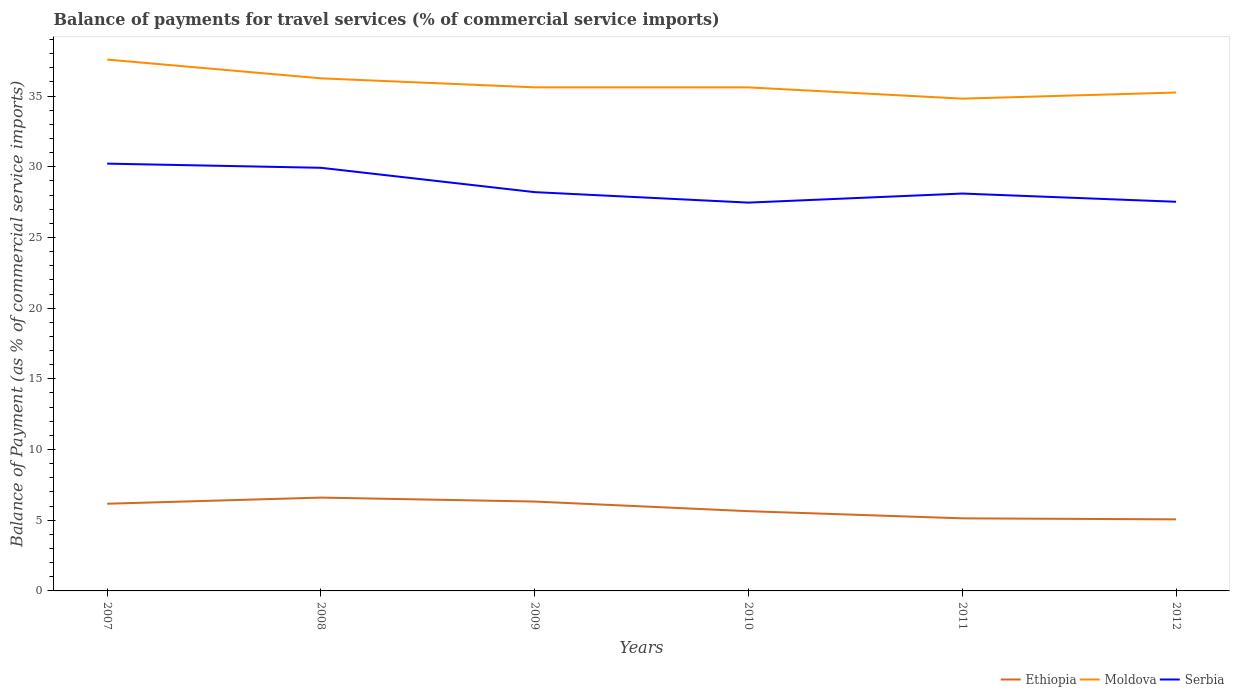How many different coloured lines are there?
Offer a terse response. 3. Across all years, what is the maximum balance of payments for travel services in Moldova?
Offer a very short reply. 34.82. What is the total balance of payments for travel services in Ethiopia in the graph?
Provide a short and direct response. 1.19. What is the difference between the highest and the second highest balance of payments for travel services in Moldova?
Your response must be concise. 2.76. What is the difference between the highest and the lowest balance of payments for travel services in Moldova?
Offer a terse response. 2. Are the values on the major ticks of Y-axis written in scientific E-notation?
Offer a terse response. No. Where does the legend appear in the graph?
Your answer should be very brief. Bottom right. How are the legend labels stacked?
Offer a very short reply. Horizontal. What is the title of the graph?
Ensure brevity in your answer.  Balance of payments for travel services (% of commercial service imports). What is the label or title of the Y-axis?
Your answer should be compact. Balance of Payment (as % of commercial service imports). What is the Balance of Payment (as % of commercial service imports) of Ethiopia in 2007?
Make the answer very short. 6.17. What is the Balance of Payment (as % of commercial service imports) of Moldova in 2007?
Give a very brief answer. 37.58. What is the Balance of Payment (as % of commercial service imports) of Serbia in 2007?
Offer a very short reply. 30.22. What is the Balance of Payment (as % of commercial service imports) of Ethiopia in 2008?
Provide a short and direct response. 6.6. What is the Balance of Payment (as % of commercial service imports) in Moldova in 2008?
Make the answer very short. 36.26. What is the Balance of Payment (as % of commercial service imports) of Serbia in 2008?
Your answer should be compact. 29.93. What is the Balance of Payment (as % of commercial service imports) of Ethiopia in 2009?
Ensure brevity in your answer.  6.32. What is the Balance of Payment (as % of commercial service imports) in Moldova in 2009?
Make the answer very short. 35.62. What is the Balance of Payment (as % of commercial service imports) of Serbia in 2009?
Keep it short and to the point. 28.21. What is the Balance of Payment (as % of commercial service imports) in Ethiopia in 2010?
Ensure brevity in your answer.  5.64. What is the Balance of Payment (as % of commercial service imports) in Moldova in 2010?
Ensure brevity in your answer.  35.61. What is the Balance of Payment (as % of commercial service imports) in Serbia in 2010?
Give a very brief answer. 27.47. What is the Balance of Payment (as % of commercial service imports) in Ethiopia in 2011?
Your response must be concise. 5.13. What is the Balance of Payment (as % of commercial service imports) in Moldova in 2011?
Your answer should be compact. 34.82. What is the Balance of Payment (as % of commercial service imports) of Serbia in 2011?
Provide a succinct answer. 28.11. What is the Balance of Payment (as % of commercial service imports) of Ethiopia in 2012?
Your response must be concise. 5.06. What is the Balance of Payment (as % of commercial service imports) of Moldova in 2012?
Give a very brief answer. 35.25. What is the Balance of Payment (as % of commercial service imports) of Serbia in 2012?
Offer a terse response. 27.53. Across all years, what is the maximum Balance of Payment (as % of commercial service imports) in Ethiopia?
Keep it short and to the point. 6.6. Across all years, what is the maximum Balance of Payment (as % of commercial service imports) in Moldova?
Your response must be concise. 37.58. Across all years, what is the maximum Balance of Payment (as % of commercial service imports) of Serbia?
Your answer should be very brief. 30.22. Across all years, what is the minimum Balance of Payment (as % of commercial service imports) in Ethiopia?
Provide a short and direct response. 5.06. Across all years, what is the minimum Balance of Payment (as % of commercial service imports) in Moldova?
Ensure brevity in your answer.  34.82. Across all years, what is the minimum Balance of Payment (as % of commercial service imports) of Serbia?
Give a very brief answer. 27.47. What is the total Balance of Payment (as % of commercial service imports) in Ethiopia in the graph?
Provide a succinct answer. 34.92. What is the total Balance of Payment (as % of commercial service imports) in Moldova in the graph?
Your answer should be very brief. 215.14. What is the total Balance of Payment (as % of commercial service imports) of Serbia in the graph?
Provide a succinct answer. 171.45. What is the difference between the Balance of Payment (as % of commercial service imports) of Ethiopia in 2007 and that in 2008?
Provide a short and direct response. -0.43. What is the difference between the Balance of Payment (as % of commercial service imports) of Moldova in 2007 and that in 2008?
Give a very brief answer. 1.33. What is the difference between the Balance of Payment (as % of commercial service imports) in Serbia in 2007 and that in 2008?
Offer a terse response. 0.29. What is the difference between the Balance of Payment (as % of commercial service imports) of Ethiopia in 2007 and that in 2009?
Keep it short and to the point. -0.15. What is the difference between the Balance of Payment (as % of commercial service imports) in Moldova in 2007 and that in 2009?
Your response must be concise. 1.96. What is the difference between the Balance of Payment (as % of commercial service imports) of Serbia in 2007 and that in 2009?
Provide a succinct answer. 2.02. What is the difference between the Balance of Payment (as % of commercial service imports) of Ethiopia in 2007 and that in 2010?
Your response must be concise. 0.53. What is the difference between the Balance of Payment (as % of commercial service imports) in Moldova in 2007 and that in 2010?
Your response must be concise. 1.97. What is the difference between the Balance of Payment (as % of commercial service imports) of Serbia in 2007 and that in 2010?
Make the answer very short. 2.76. What is the difference between the Balance of Payment (as % of commercial service imports) in Ethiopia in 2007 and that in 2011?
Offer a very short reply. 1.03. What is the difference between the Balance of Payment (as % of commercial service imports) in Moldova in 2007 and that in 2011?
Provide a succinct answer. 2.76. What is the difference between the Balance of Payment (as % of commercial service imports) of Serbia in 2007 and that in 2011?
Provide a succinct answer. 2.12. What is the difference between the Balance of Payment (as % of commercial service imports) of Ethiopia in 2007 and that in 2012?
Offer a very short reply. 1.1. What is the difference between the Balance of Payment (as % of commercial service imports) of Moldova in 2007 and that in 2012?
Offer a very short reply. 2.33. What is the difference between the Balance of Payment (as % of commercial service imports) of Serbia in 2007 and that in 2012?
Give a very brief answer. 2.7. What is the difference between the Balance of Payment (as % of commercial service imports) in Ethiopia in 2008 and that in 2009?
Ensure brevity in your answer.  0.28. What is the difference between the Balance of Payment (as % of commercial service imports) in Moldova in 2008 and that in 2009?
Provide a succinct answer. 0.64. What is the difference between the Balance of Payment (as % of commercial service imports) of Serbia in 2008 and that in 2009?
Make the answer very short. 1.72. What is the difference between the Balance of Payment (as % of commercial service imports) in Ethiopia in 2008 and that in 2010?
Provide a succinct answer. 0.96. What is the difference between the Balance of Payment (as % of commercial service imports) in Moldova in 2008 and that in 2010?
Make the answer very short. 0.64. What is the difference between the Balance of Payment (as % of commercial service imports) in Serbia in 2008 and that in 2010?
Keep it short and to the point. 2.46. What is the difference between the Balance of Payment (as % of commercial service imports) of Ethiopia in 2008 and that in 2011?
Provide a short and direct response. 1.47. What is the difference between the Balance of Payment (as % of commercial service imports) of Moldova in 2008 and that in 2011?
Your response must be concise. 1.44. What is the difference between the Balance of Payment (as % of commercial service imports) of Serbia in 2008 and that in 2011?
Provide a succinct answer. 1.82. What is the difference between the Balance of Payment (as % of commercial service imports) in Ethiopia in 2008 and that in 2012?
Offer a very short reply. 1.54. What is the difference between the Balance of Payment (as % of commercial service imports) in Moldova in 2008 and that in 2012?
Your response must be concise. 1. What is the difference between the Balance of Payment (as % of commercial service imports) in Serbia in 2008 and that in 2012?
Your response must be concise. 2.4. What is the difference between the Balance of Payment (as % of commercial service imports) in Ethiopia in 2009 and that in 2010?
Provide a short and direct response. 0.68. What is the difference between the Balance of Payment (as % of commercial service imports) in Moldova in 2009 and that in 2010?
Your answer should be compact. 0. What is the difference between the Balance of Payment (as % of commercial service imports) of Serbia in 2009 and that in 2010?
Your answer should be very brief. 0.74. What is the difference between the Balance of Payment (as % of commercial service imports) in Ethiopia in 2009 and that in 2011?
Give a very brief answer. 1.19. What is the difference between the Balance of Payment (as % of commercial service imports) of Moldova in 2009 and that in 2011?
Offer a terse response. 0.8. What is the difference between the Balance of Payment (as % of commercial service imports) in Serbia in 2009 and that in 2011?
Make the answer very short. 0.1. What is the difference between the Balance of Payment (as % of commercial service imports) in Ethiopia in 2009 and that in 2012?
Your answer should be very brief. 1.26. What is the difference between the Balance of Payment (as % of commercial service imports) of Moldova in 2009 and that in 2012?
Your response must be concise. 0.37. What is the difference between the Balance of Payment (as % of commercial service imports) in Serbia in 2009 and that in 2012?
Provide a short and direct response. 0.68. What is the difference between the Balance of Payment (as % of commercial service imports) in Ethiopia in 2010 and that in 2011?
Offer a terse response. 0.51. What is the difference between the Balance of Payment (as % of commercial service imports) in Moldova in 2010 and that in 2011?
Provide a short and direct response. 0.8. What is the difference between the Balance of Payment (as % of commercial service imports) of Serbia in 2010 and that in 2011?
Your answer should be very brief. -0.64. What is the difference between the Balance of Payment (as % of commercial service imports) of Ethiopia in 2010 and that in 2012?
Keep it short and to the point. 0.58. What is the difference between the Balance of Payment (as % of commercial service imports) of Moldova in 2010 and that in 2012?
Provide a short and direct response. 0.36. What is the difference between the Balance of Payment (as % of commercial service imports) of Serbia in 2010 and that in 2012?
Offer a very short reply. -0.06. What is the difference between the Balance of Payment (as % of commercial service imports) in Ethiopia in 2011 and that in 2012?
Your answer should be compact. 0.07. What is the difference between the Balance of Payment (as % of commercial service imports) of Moldova in 2011 and that in 2012?
Your answer should be compact. -0.43. What is the difference between the Balance of Payment (as % of commercial service imports) of Serbia in 2011 and that in 2012?
Make the answer very short. 0.58. What is the difference between the Balance of Payment (as % of commercial service imports) in Ethiopia in 2007 and the Balance of Payment (as % of commercial service imports) in Moldova in 2008?
Ensure brevity in your answer.  -30.09. What is the difference between the Balance of Payment (as % of commercial service imports) in Ethiopia in 2007 and the Balance of Payment (as % of commercial service imports) in Serbia in 2008?
Keep it short and to the point. -23.76. What is the difference between the Balance of Payment (as % of commercial service imports) of Moldova in 2007 and the Balance of Payment (as % of commercial service imports) of Serbia in 2008?
Make the answer very short. 7.66. What is the difference between the Balance of Payment (as % of commercial service imports) in Ethiopia in 2007 and the Balance of Payment (as % of commercial service imports) in Moldova in 2009?
Provide a short and direct response. -29.45. What is the difference between the Balance of Payment (as % of commercial service imports) of Ethiopia in 2007 and the Balance of Payment (as % of commercial service imports) of Serbia in 2009?
Your response must be concise. -22.04. What is the difference between the Balance of Payment (as % of commercial service imports) of Moldova in 2007 and the Balance of Payment (as % of commercial service imports) of Serbia in 2009?
Make the answer very short. 9.38. What is the difference between the Balance of Payment (as % of commercial service imports) of Ethiopia in 2007 and the Balance of Payment (as % of commercial service imports) of Moldova in 2010?
Keep it short and to the point. -29.45. What is the difference between the Balance of Payment (as % of commercial service imports) of Ethiopia in 2007 and the Balance of Payment (as % of commercial service imports) of Serbia in 2010?
Give a very brief answer. -21.3. What is the difference between the Balance of Payment (as % of commercial service imports) of Moldova in 2007 and the Balance of Payment (as % of commercial service imports) of Serbia in 2010?
Provide a succinct answer. 10.12. What is the difference between the Balance of Payment (as % of commercial service imports) in Ethiopia in 2007 and the Balance of Payment (as % of commercial service imports) in Moldova in 2011?
Offer a terse response. -28.65. What is the difference between the Balance of Payment (as % of commercial service imports) in Ethiopia in 2007 and the Balance of Payment (as % of commercial service imports) in Serbia in 2011?
Your response must be concise. -21.94. What is the difference between the Balance of Payment (as % of commercial service imports) in Moldova in 2007 and the Balance of Payment (as % of commercial service imports) in Serbia in 2011?
Keep it short and to the point. 9.48. What is the difference between the Balance of Payment (as % of commercial service imports) in Ethiopia in 2007 and the Balance of Payment (as % of commercial service imports) in Moldova in 2012?
Provide a short and direct response. -29.08. What is the difference between the Balance of Payment (as % of commercial service imports) of Ethiopia in 2007 and the Balance of Payment (as % of commercial service imports) of Serbia in 2012?
Offer a terse response. -21.36. What is the difference between the Balance of Payment (as % of commercial service imports) of Moldova in 2007 and the Balance of Payment (as % of commercial service imports) of Serbia in 2012?
Give a very brief answer. 10.06. What is the difference between the Balance of Payment (as % of commercial service imports) of Ethiopia in 2008 and the Balance of Payment (as % of commercial service imports) of Moldova in 2009?
Offer a terse response. -29.02. What is the difference between the Balance of Payment (as % of commercial service imports) in Ethiopia in 2008 and the Balance of Payment (as % of commercial service imports) in Serbia in 2009?
Your answer should be compact. -21.61. What is the difference between the Balance of Payment (as % of commercial service imports) of Moldova in 2008 and the Balance of Payment (as % of commercial service imports) of Serbia in 2009?
Ensure brevity in your answer.  8.05. What is the difference between the Balance of Payment (as % of commercial service imports) of Ethiopia in 2008 and the Balance of Payment (as % of commercial service imports) of Moldova in 2010?
Keep it short and to the point. -29.01. What is the difference between the Balance of Payment (as % of commercial service imports) of Ethiopia in 2008 and the Balance of Payment (as % of commercial service imports) of Serbia in 2010?
Give a very brief answer. -20.86. What is the difference between the Balance of Payment (as % of commercial service imports) of Moldova in 2008 and the Balance of Payment (as % of commercial service imports) of Serbia in 2010?
Ensure brevity in your answer.  8.79. What is the difference between the Balance of Payment (as % of commercial service imports) in Ethiopia in 2008 and the Balance of Payment (as % of commercial service imports) in Moldova in 2011?
Your answer should be compact. -28.22. What is the difference between the Balance of Payment (as % of commercial service imports) in Ethiopia in 2008 and the Balance of Payment (as % of commercial service imports) in Serbia in 2011?
Your response must be concise. -21.51. What is the difference between the Balance of Payment (as % of commercial service imports) of Moldova in 2008 and the Balance of Payment (as % of commercial service imports) of Serbia in 2011?
Ensure brevity in your answer.  8.15. What is the difference between the Balance of Payment (as % of commercial service imports) in Ethiopia in 2008 and the Balance of Payment (as % of commercial service imports) in Moldova in 2012?
Provide a succinct answer. -28.65. What is the difference between the Balance of Payment (as % of commercial service imports) of Ethiopia in 2008 and the Balance of Payment (as % of commercial service imports) of Serbia in 2012?
Your response must be concise. -20.92. What is the difference between the Balance of Payment (as % of commercial service imports) of Moldova in 2008 and the Balance of Payment (as % of commercial service imports) of Serbia in 2012?
Ensure brevity in your answer.  8.73. What is the difference between the Balance of Payment (as % of commercial service imports) in Ethiopia in 2009 and the Balance of Payment (as % of commercial service imports) in Moldova in 2010?
Provide a short and direct response. -29.29. What is the difference between the Balance of Payment (as % of commercial service imports) of Ethiopia in 2009 and the Balance of Payment (as % of commercial service imports) of Serbia in 2010?
Give a very brief answer. -21.14. What is the difference between the Balance of Payment (as % of commercial service imports) in Moldova in 2009 and the Balance of Payment (as % of commercial service imports) in Serbia in 2010?
Your response must be concise. 8.15. What is the difference between the Balance of Payment (as % of commercial service imports) in Ethiopia in 2009 and the Balance of Payment (as % of commercial service imports) in Moldova in 2011?
Provide a short and direct response. -28.5. What is the difference between the Balance of Payment (as % of commercial service imports) in Ethiopia in 2009 and the Balance of Payment (as % of commercial service imports) in Serbia in 2011?
Your answer should be compact. -21.78. What is the difference between the Balance of Payment (as % of commercial service imports) of Moldova in 2009 and the Balance of Payment (as % of commercial service imports) of Serbia in 2011?
Give a very brief answer. 7.51. What is the difference between the Balance of Payment (as % of commercial service imports) in Ethiopia in 2009 and the Balance of Payment (as % of commercial service imports) in Moldova in 2012?
Offer a very short reply. -28.93. What is the difference between the Balance of Payment (as % of commercial service imports) in Ethiopia in 2009 and the Balance of Payment (as % of commercial service imports) in Serbia in 2012?
Give a very brief answer. -21.2. What is the difference between the Balance of Payment (as % of commercial service imports) of Moldova in 2009 and the Balance of Payment (as % of commercial service imports) of Serbia in 2012?
Your answer should be compact. 8.09. What is the difference between the Balance of Payment (as % of commercial service imports) in Ethiopia in 2010 and the Balance of Payment (as % of commercial service imports) in Moldova in 2011?
Provide a short and direct response. -29.18. What is the difference between the Balance of Payment (as % of commercial service imports) of Ethiopia in 2010 and the Balance of Payment (as % of commercial service imports) of Serbia in 2011?
Your response must be concise. -22.47. What is the difference between the Balance of Payment (as % of commercial service imports) in Moldova in 2010 and the Balance of Payment (as % of commercial service imports) in Serbia in 2011?
Offer a terse response. 7.51. What is the difference between the Balance of Payment (as % of commercial service imports) of Ethiopia in 2010 and the Balance of Payment (as % of commercial service imports) of Moldova in 2012?
Your answer should be very brief. -29.61. What is the difference between the Balance of Payment (as % of commercial service imports) in Ethiopia in 2010 and the Balance of Payment (as % of commercial service imports) in Serbia in 2012?
Provide a succinct answer. -21.89. What is the difference between the Balance of Payment (as % of commercial service imports) in Moldova in 2010 and the Balance of Payment (as % of commercial service imports) in Serbia in 2012?
Ensure brevity in your answer.  8.09. What is the difference between the Balance of Payment (as % of commercial service imports) of Ethiopia in 2011 and the Balance of Payment (as % of commercial service imports) of Moldova in 2012?
Your answer should be very brief. -30.12. What is the difference between the Balance of Payment (as % of commercial service imports) in Ethiopia in 2011 and the Balance of Payment (as % of commercial service imports) in Serbia in 2012?
Your answer should be compact. -22.39. What is the difference between the Balance of Payment (as % of commercial service imports) in Moldova in 2011 and the Balance of Payment (as % of commercial service imports) in Serbia in 2012?
Your response must be concise. 7.29. What is the average Balance of Payment (as % of commercial service imports) in Ethiopia per year?
Make the answer very short. 5.82. What is the average Balance of Payment (as % of commercial service imports) of Moldova per year?
Your answer should be compact. 35.86. What is the average Balance of Payment (as % of commercial service imports) of Serbia per year?
Provide a succinct answer. 28.58. In the year 2007, what is the difference between the Balance of Payment (as % of commercial service imports) of Ethiopia and Balance of Payment (as % of commercial service imports) of Moldova?
Provide a succinct answer. -31.42. In the year 2007, what is the difference between the Balance of Payment (as % of commercial service imports) in Ethiopia and Balance of Payment (as % of commercial service imports) in Serbia?
Your answer should be very brief. -24.06. In the year 2007, what is the difference between the Balance of Payment (as % of commercial service imports) of Moldova and Balance of Payment (as % of commercial service imports) of Serbia?
Provide a succinct answer. 7.36. In the year 2008, what is the difference between the Balance of Payment (as % of commercial service imports) in Ethiopia and Balance of Payment (as % of commercial service imports) in Moldova?
Provide a succinct answer. -29.65. In the year 2008, what is the difference between the Balance of Payment (as % of commercial service imports) of Ethiopia and Balance of Payment (as % of commercial service imports) of Serbia?
Make the answer very short. -23.33. In the year 2008, what is the difference between the Balance of Payment (as % of commercial service imports) of Moldova and Balance of Payment (as % of commercial service imports) of Serbia?
Ensure brevity in your answer.  6.33. In the year 2009, what is the difference between the Balance of Payment (as % of commercial service imports) in Ethiopia and Balance of Payment (as % of commercial service imports) in Moldova?
Provide a succinct answer. -29.3. In the year 2009, what is the difference between the Balance of Payment (as % of commercial service imports) in Ethiopia and Balance of Payment (as % of commercial service imports) in Serbia?
Your answer should be compact. -21.89. In the year 2009, what is the difference between the Balance of Payment (as % of commercial service imports) of Moldova and Balance of Payment (as % of commercial service imports) of Serbia?
Provide a succinct answer. 7.41. In the year 2010, what is the difference between the Balance of Payment (as % of commercial service imports) of Ethiopia and Balance of Payment (as % of commercial service imports) of Moldova?
Give a very brief answer. -29.97. In the year 2010, what is the difference between the Balance of Payment (as % of commercial service imports) in Ethiopia and Balance of Payment (as % of commercial service imports) in Serbia?
Your answer should be compact. -21.83. In the year 2010, what is the difference between the Balance of Payment (as % of commercial service imports) in Moldova and Balance of Payment (as % of commercial service imports) in Serbia?
Offer a terse response. 8.15. In the year 2011, what is the difference between the Balance of Payment (as % of commercial service imports) of Ethiopia and Balance of Payment (as % of commercial service imports) of Moldova?
Provide a short and direct response. -29.69. In the year 2011, what is the difference between the Balance of Payment (as % of commercial service imports) in Ethiopia and Balance of Payment (as % of commercial service imports) in Serbia?
Your answer should be very brief. -22.97. In the year 2011, what is the difference between the Balance of Payment (as % of commercial service imports) of Moldova and Balance of Payment (as % of commercial service imports) of Serbia?
Your answer should be very brief. 6.71. In the year 2012, what is the difference between the Balance of Payment (as % of commercial service imports) in Ethiopia and Balance of Payment (as % of commercial service imports) in Moldova?
Provide a short and direct response. -30.19. In the year 2012, what is the difference between the Balance of Payment (as % of commercial service imports) of Ethiopia and Balance of Payment (as % of commercial service imports) of Serbia?
Offer a terse response. -22.46. In the year 2012, what is the difference between the Balance of Payment (as % of commercial service imports) of Moldova and Balance of Payment (as % of commercial service imports) of Serbia?
Keep it short and to the point. 7.73. What is the ratio of the Balance of Payment (as % of commercial service imports) of Ethiopia in 2007 to that in 2008?
Your answer should be very brief. 0.93. What is the ratio of the Balance of Payment (as % of commercial service imports) in Moldova in 2007 to that in 2008?
Offer a very short reply. 1.04. What is the ratio of the Balance of Payment (as % of commercial service imports) in Serbia in 2007 to that in 2008?
Provide a short and direct response. 1.01. What is the ratio of the Balance of Payment (as % of commercial service imports) in Ethiopia in 2007 to that in 2009?
Provide a succinct answer. 0.98. What is the ratio of the Balance of Payment (as % of commercial service imports) of Moldova in 2007 to that in 2009?
Ensure brevity in your answer.  1.06. What is the ratio of the Balance of Payment (as % of commercial service imports) of Serbia in 2007 to that in 2009?
Offer a terse response. 1.07. What is the ratio of the Balance of Payment (as % of commercial service imports) in Ethiopia in 2007 to that in 2010?
Give a very brief answer. 1.09. What is the ratio of the Balance of Payment (as % of commercial service imports) in Moldova in 2007 to that in 2010?
Your answer should be very brief. 1.06. What is the ratio of the Balance of Payment (as % of commercial service imports) in Serbia in 2007 to that in 2010?
Provide a succinct answer. 1.1. What is the ratio of the Balance of Payment (as % of commercial service imports) in Ethiopia in 2007 to that in 2011?
Make the answer very short. 1.2. What is the ratio of the Balance of Payment (as % of commercial service imports) in Moldova in 2007 to that in 2011?
Make the answer very short. 1.08. What is the ratio of the Balance of Payment (as % of commercial service imports) in Serbia in 2007 to that in 2011?
Offer a terse response. 1.08. What is the ratio of the Balance of Payment (as % of commercial service imports) of Ethiopia in 2007 to that in 2012?
Your answer should be compact. 1.22. What is the ratio of the Balance of Payment (as % of commercial service imports) in Moldova in 2007 to that in 2012?
Provide a succinct answer. 1.07. What is the ratio of the Balance of Payment (as % of commercial service imports) of Serbia in 2007 to that in 2012?
Your answer should be compact. 1.1. What is the ratio of the Balance of Payment (as % of commercial service imports) of Ethiopia in 2008 to that in 2009?
Offer a very short reply. 1.04. What is the ratio of the Balance of Payment (as % of commercial service imports) of Moldova in 2008 to that in 2009?
Make the answer very short. 1.02. What is the ratio of the Balance of Payment (as % of commercial service imports) in Serbia in 2008 to that in 2009?
Give a very brief answer. 1.06. What is the ratio of the Balance of Payment (as % of commercial service imports) of Ethiopia in 2008 to that in 2010?
Ensure brevity in your answer.  1.17. What is the ratio of the Balance of Payment (as % of commercial service imports) of Serbia in 2008 to that in 2010?
Offer a very short reply. 1.09. What is the ratio of the Balance of Payment (as % of commercial service imports) of Moldova in 2008 to that in 2011?
Ensure brevity in your answer.  1.04. What is the ratio of the Balance of Payment (as % of commercial service imports) of Serbia in 2008 to that in 2011?
Provide a succinct answer. 1.06. What is the ratio of the Balance of Payment (as % of commercial service imports) of Ethiopia in 2008 to that in 2012?
Provide a short and direct response. 1.3. What is the ratio of the Balance of Payment (as % of commercial service imports) in Moldova in 2008 to that in 2012?
Provide a short and direct response. 1.03. What is the ratio of the Balance of Payment (as % of commercial service imports) in Serbia in 2008 to that in 2012?
Your answer should be very brief. 1.09. What is the ratio of the Balance of Payment (as % of commercial service imports) of Ethiopia in 2009 to that in 2010?
Offer a very short reply. 1.12. What is the ratio of the Balance of Payment (as % of commercial service imports) of Serbia in 2009 to that in 2010?
Provide a short and direct response. 1.03. What is the ratio of the Balance of Payment (as % of commercial service imports) of Ethiopia in 2009 to that in 2011?
Your response must be concise. 1.23. What is the ratio of the Balance of Payment (as % of commercial service imports) of Moldova in 2009 to that in 2011?
Offer a very short reply. 1.02. What is the ratio of the Balance of Payment (as % of commercial service imports) in Ethiopia in 2009 to that in 2012?
Your answer should be very brief. 1.25. What is the ratio of the Balance of Payment (as % of commercial service imports) of Moldova in 2009 to that in 2012?
Ensure brevity in your answer.  1.01. What is the ratio of the Balance of Payment (as % of commercial service imports) in Serbia in 2009 to that in 2012?
Offer a very short reply. 1.02. What is the ratio of the Balance of Payment (as % of commercial service imports) of Ethiopia in 2010 to that in 2011?
Your answer should be compact. 1.1. What is the ratio of the Balance of Payment (as % of commercial service imports) of Moldova in 2010 to that in 2011?
Provide a succinct answer. 1.02. What is the ratio of the Balance of Payment (as % of commercial service imports) of Serbia in 2010 to that in 2011?
Provide a short and direct response. 0.98. What is the ratio of the Balance of Payment (as % of commercial service imports) in Ethiopia in 2010 to that in 2012?
Keep it short and to the point. 1.11. What is the ratio of the Balance of Payment (as % of commercial service imports) of Moldova in 2010 to that in 2012?
Offer a very short reply. 1.01. What is the ratio of the Balance of Payment (as % of commercial service imports) in Ethiopia in 2011 to that in 2012?
Give a very brief answer. 1.01. What is the ratio of the Balance of Payment (as % of commercial service imports) of Serbia in 2011 to that in 2012?
Keep it short and to the point. 1.02. What is the difference between the highest and the second highest Balance of Payment (as % of commercial service imports) of Ethiopia?
Keep it short and to the point. 0.28. What is the difference between the highest and the second highest Balance of Payment (as % of commercial service imports) in Moldova?
Provide a short and direct response. 1.33. What is the difference between the highest and the second highest Balance of Payment (as % of commercial service imports) of Serbia?
Ensure brevity in your answer.  0.29. What is the difference between the highest and the lowest Balance of Payment (as % of commercial service imports) of Ethiopia?
Provide a succinct answer. 1.54. What is the difference between the highest and the lowest Balance of Payment (as % of commercial service imports) in Moldova?
Your response must be concise. 2.76. What is the difference between the highest and the lowest Balance of Payment (as % of commercial service imports) of Serbia?
Give a very brief answer. 2.76. 